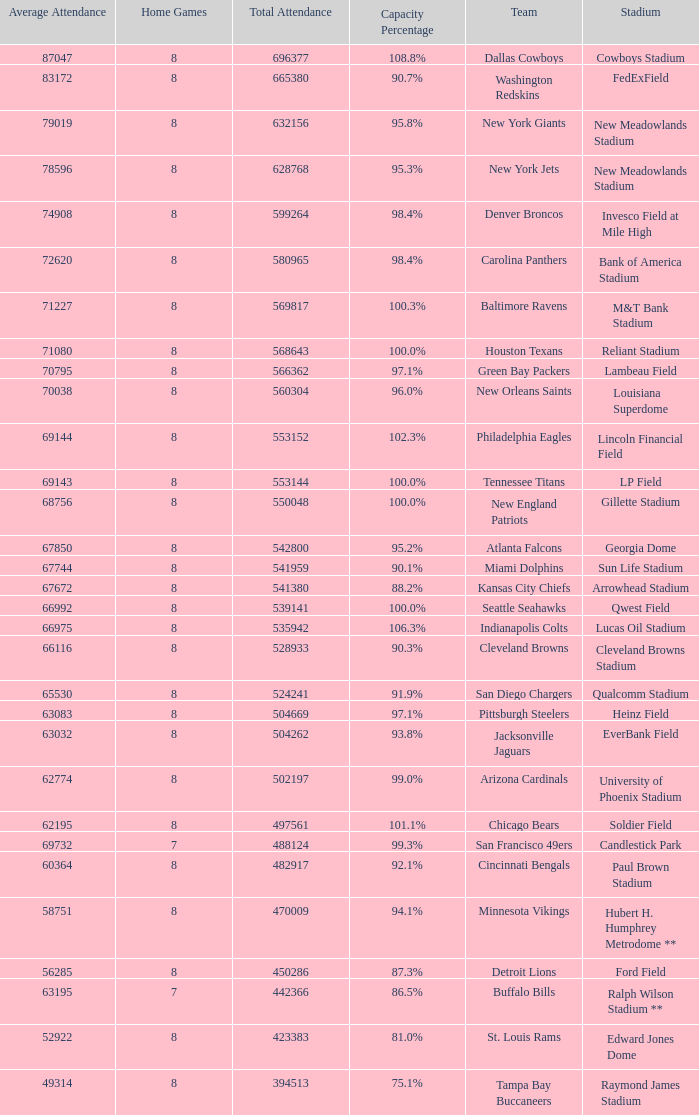What was the mean attendance when the overall attendance reached 541,380? 67672.0. 